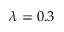<formula> <loc_0><loc_0><loc_500><loc_500>\lambda = 0 . 3</formula> 